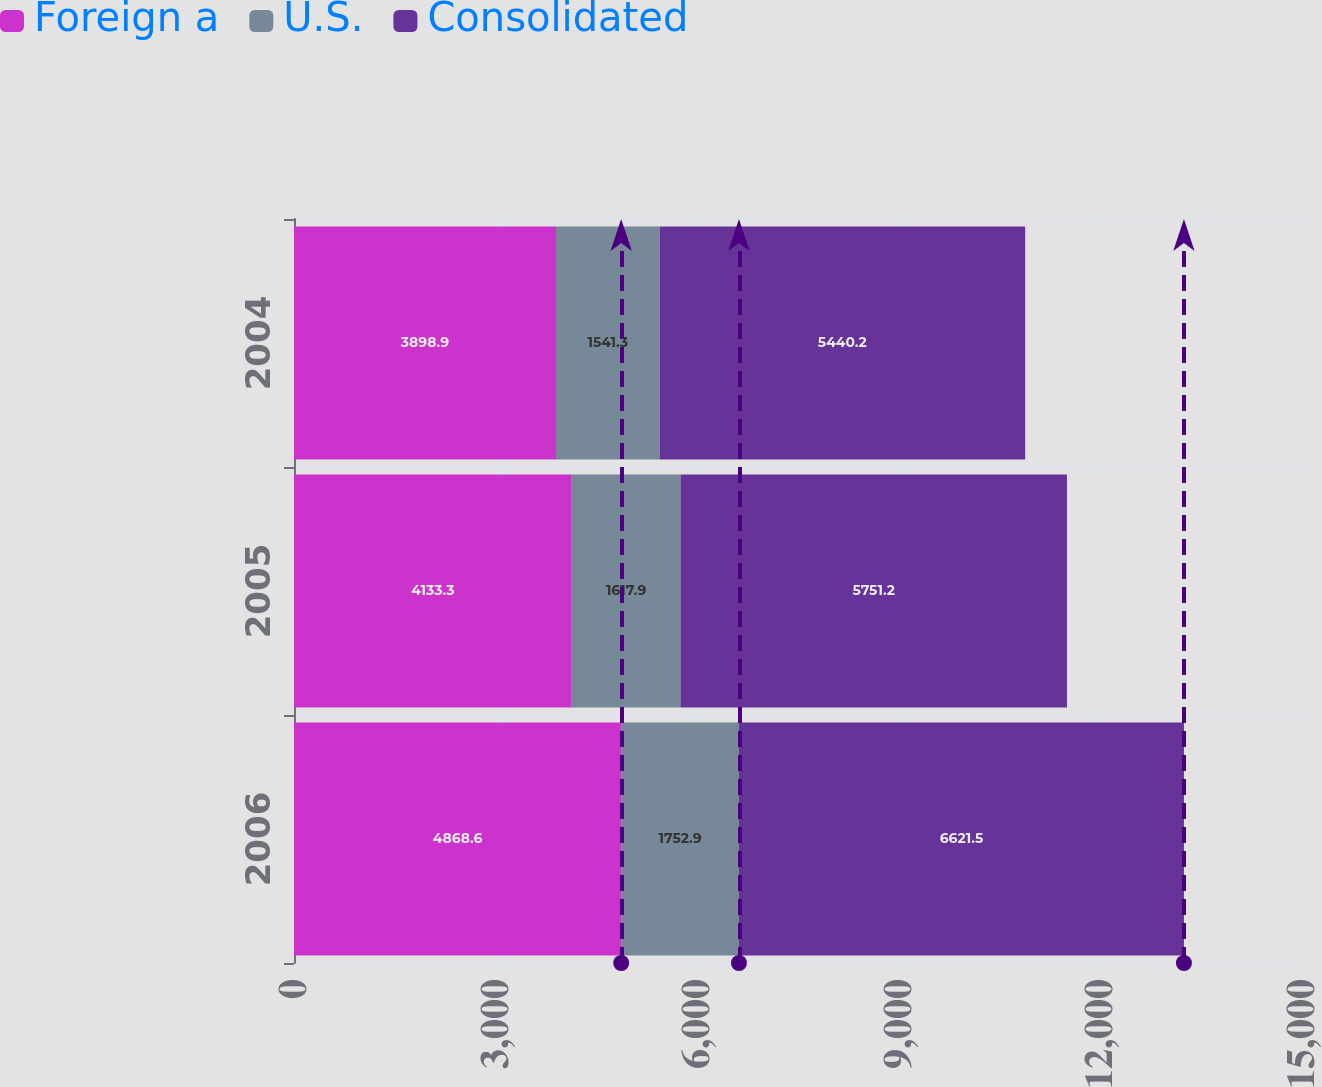Convert chart to OTSL. <chart><loc_0><loc_0><loc_500><loc_500><stacked_bar_chart><ecel><fcel>2006<fcel>2005<fcel>2004<nl><fcel>Foreign a<fcel>4868.6<fcel>4133.3<fcel>3898.9<nl><fcel>U.S.<fcel>1752.9<fcel>1617.9<fcel>1541.3<nl><fcel>Consolidated<fcel>6621.5<fcel>5751.2<fcel>5440.2<nl></chart> 